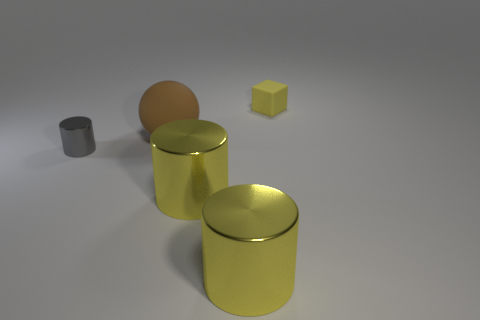Subtract all yellow cylinders. How many cylinders are left? 1 Subtract 1 balls. How many balls are left? 0 Add 4 green objects. How many objects exist? 9 Subtract all yellow cylinders. How many cylinders are left? 1 Subtract all cylinders. How many objects are left? 2 Subtract all gray cylinders. Subtract all yellow spheres. How many cylinders are left? 2 Subtract all green balls. How many red cylinders are left? 0 Subtract all matte objects. Subtract all large things. How many objects are left? 0 Add 1 big cylinders. How many big cylinders are left? 3 Add 4 brown rubber objects. How many brown rubber objects exist? 5 